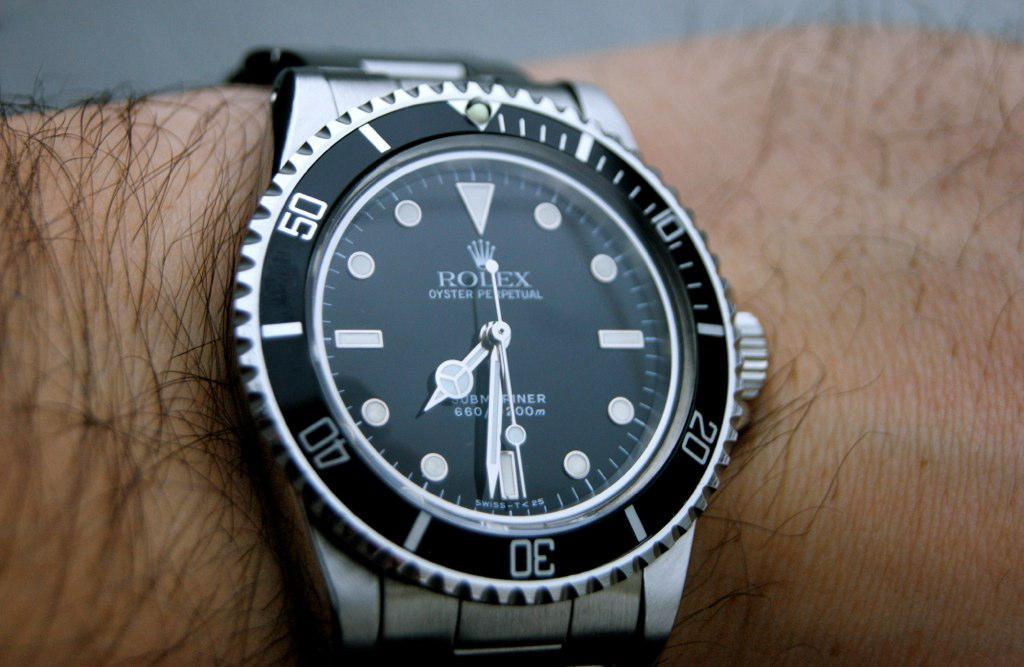<image>
Share a concise interpretation of the image provided. A Rolex watch has a black face and is on a wrist. 